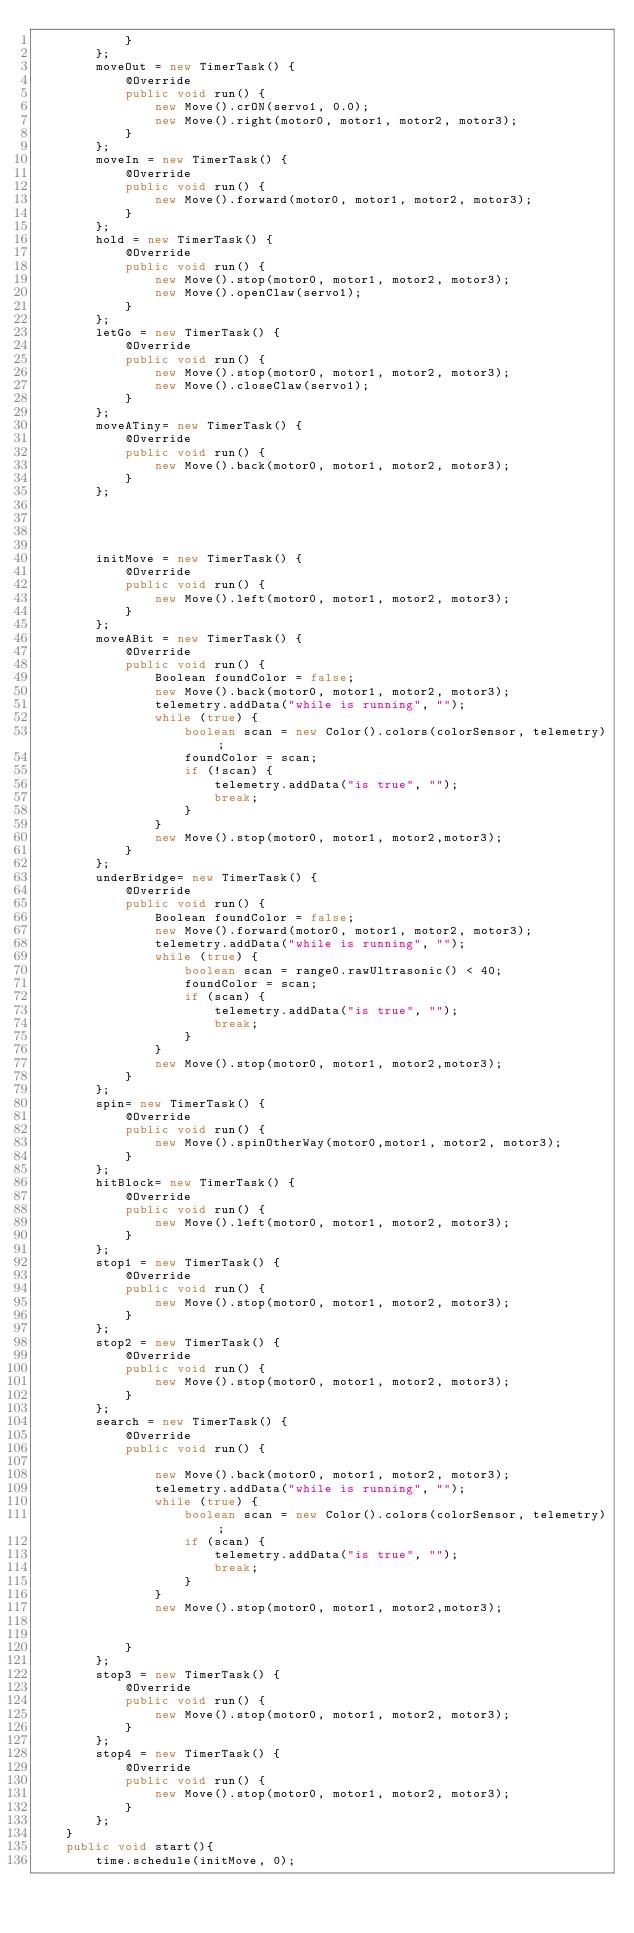Convert code to text. <code><loc_0><loc_0><loc_500><loc_500><_Java_>            }
        };
        moveOut = new TimerTask() {
            @Override
            public void run() {
                new Move().crON(servo1, 0.0);
                new Move().right(motor0, motor1, motor2, motor3);
            }
        };
        moveIn = new TimerTask() {
            @Override
            public void run() {
                new Move().forward(motor0, motor1, motor2, motor3);
            }
        };
        hold = new TimerTask() {
            @Override
            public void run() {
                new Move().stop(motor0, motor1, motor2, motor3);
                new Move().openClaw(servo1);
            }
        };
        letGo = new TimerTask() {
            @Override
            public void run() {
                new Move().stop(motor0, motor1, motor2, motor3);
                new Move().closeClaw(servo1);
            }
        };
        moveATiny= new TimerTask() {
            @Override
            public void run() {
                new Move().back(motor0, motor1, motor2, motor3);
            }
        };




        initMove = new TimerTask() {
            @Override
            public void run() {
                new Move().left(motor0, motor1, motor2, motor3);
            }
        };
        moveABit = new TimerTask() {
            @Override
            public void run() {
                Boolean foundColor = false;
                new Move().back(motor0, motor1, motor2, motor3);
                telemetry.addData("while is running", "");
                while (true) {
                    boolean scan = new Color().colors(colorSensor, telemetry);
                    foundColor = scan;
                    if (!scan) {
                        telemetry.addData("is true", "");
                        break;
                    }
                }
                new Move().stop(motor0, motor1, motor2,motor3);
            }
        };
        underBridge= new TimerTask() {
            @Override
            public void run() {
                Boolean foundColor = false;
                new Move().forward(motor0, motor1, motor2, motor3);
                telemetry.addData("while is running", "");
                while (true) {
                    boolean scan = range0.rawUltrasonic() < 40;
                    foundColor = scan;
                    if (scan) {
                        telemetry.addData("is true", "");
                        break;
                    }
                }
                new Move().stop(motor0, motor1, motor2,motor3);
            }
        };
        spin= new TimerTask() {
            @Override
            public void run() {
                new Move().spinOtherWay(motor0,motor1, motor2, motor3);
            }
        };
        hitBlock= new TimerTask() {
            @Override
            public void run() {
                new Move().left(motor0, motor1, motor2, motor3);
            }
        };
        stop1 = new TimerTask() {
            @Override
            public void run() {
                new Move().stop(motor0, motor1, motor2, motor3);
            }
        };
        stop2 = new TimerTask() {
            @Override
            public void run() {
                new Move().stop(motor0, motor1, motor2, motor3);
            }
        };
        search = new TimerTask() {
            @Override
            public void run() {

                new Move().back(motor0, motor1, motor2, motor3);
                telemetry.addData("while is running", "");
                while (true) {
                    boolean scan = new Color().colors(colorSensor, telemetry);
                    if (scan) {
                        telemetry.addData("is true", "");
                        break;
                    }
                }
                new Move().stop(motor0, motor1, motor2,motor3);


            }
        };
        stop3 = new TimerTask() {
            @Override
            public void run() {
                new Move().stop(motor0, motor1, motor2, motor3);
            }
        };
        stop4 = new TimerTask() {
            @Override
            public void run() {
                new Move().stop(motor0, motor1, motor2, motor3);
            }
        };
    }
    public void start(){
        time.schedule(initMove, 0);</code> 